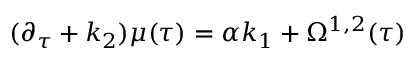Convert formula to latex. <formula><loc_0><loc_0><loc_500><loc_500>{ } ( \partial _ { \tau } + k _ { 2 } ) \mu ( \tau ) = \alpha k _ { 1 } + \Omega ^ { 1 , 2 } ( \tau )</formula> 